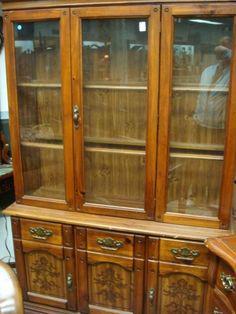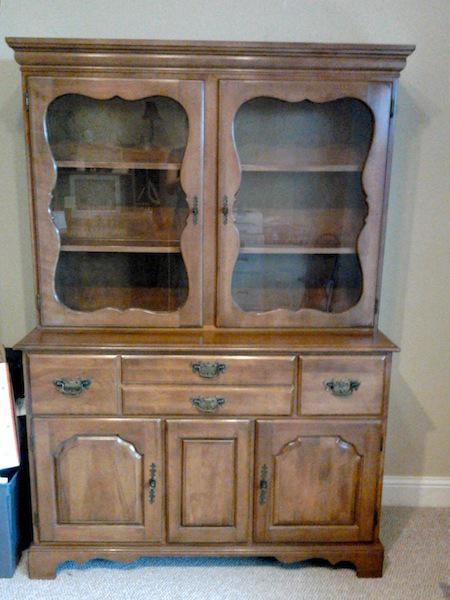The first image is the image on the left, the second image is the image on the right. Examine the images to the left and right. Is the description "All images show a piece of furniture with drawers" accurate? Answer yes or no. Yes. 